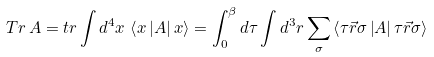Convert formula to latex. <formula><loc_0><loc_0><loc_500><loc_500>T r \, A = t r \int d ^ { 4 } x \, \left \langle x \left | A \right | x \right \rangle = \int _ { 0 } ^ { \beta } d \tau \int d ^ { 3 } r \sum _ { \sigma } \left \langle \tau \vec { r } \sigma \left | A \right | \tau \vec { r } \sigma \right \rangle</formula> 